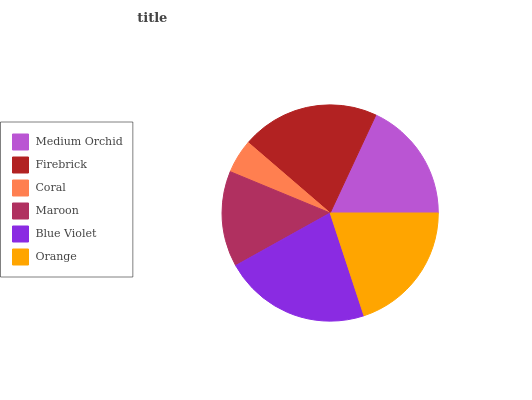Is Coral the minimum?
Answer yes or no. Yes. Is Blue Violet the maximum?
Answer yes or no. Yes. Is Firebrick the minimum?
Answer yes or no. No. Is Firebrick the maximum?
Answer yes or no. No. Is Firebrick greater than Medium Orchid?
Answer yes or no. Yes. Is Medium Orchid less than Firebrick?
Answer yes or no. Yes. Is Medium Orchid greater than Firebrick?
Answer yes or no. No. Is Firebrick less than Medium Orchid?
Answer yes or no. No. Is Orange the high median?
Answer yes or no. Yes. Is Medium Orchid the low median?
Answer yes or no. Yes. Is Blue Violet the high median?
Answer yes or no. No. Is Coral the low median?
Answer yes or no. No. 